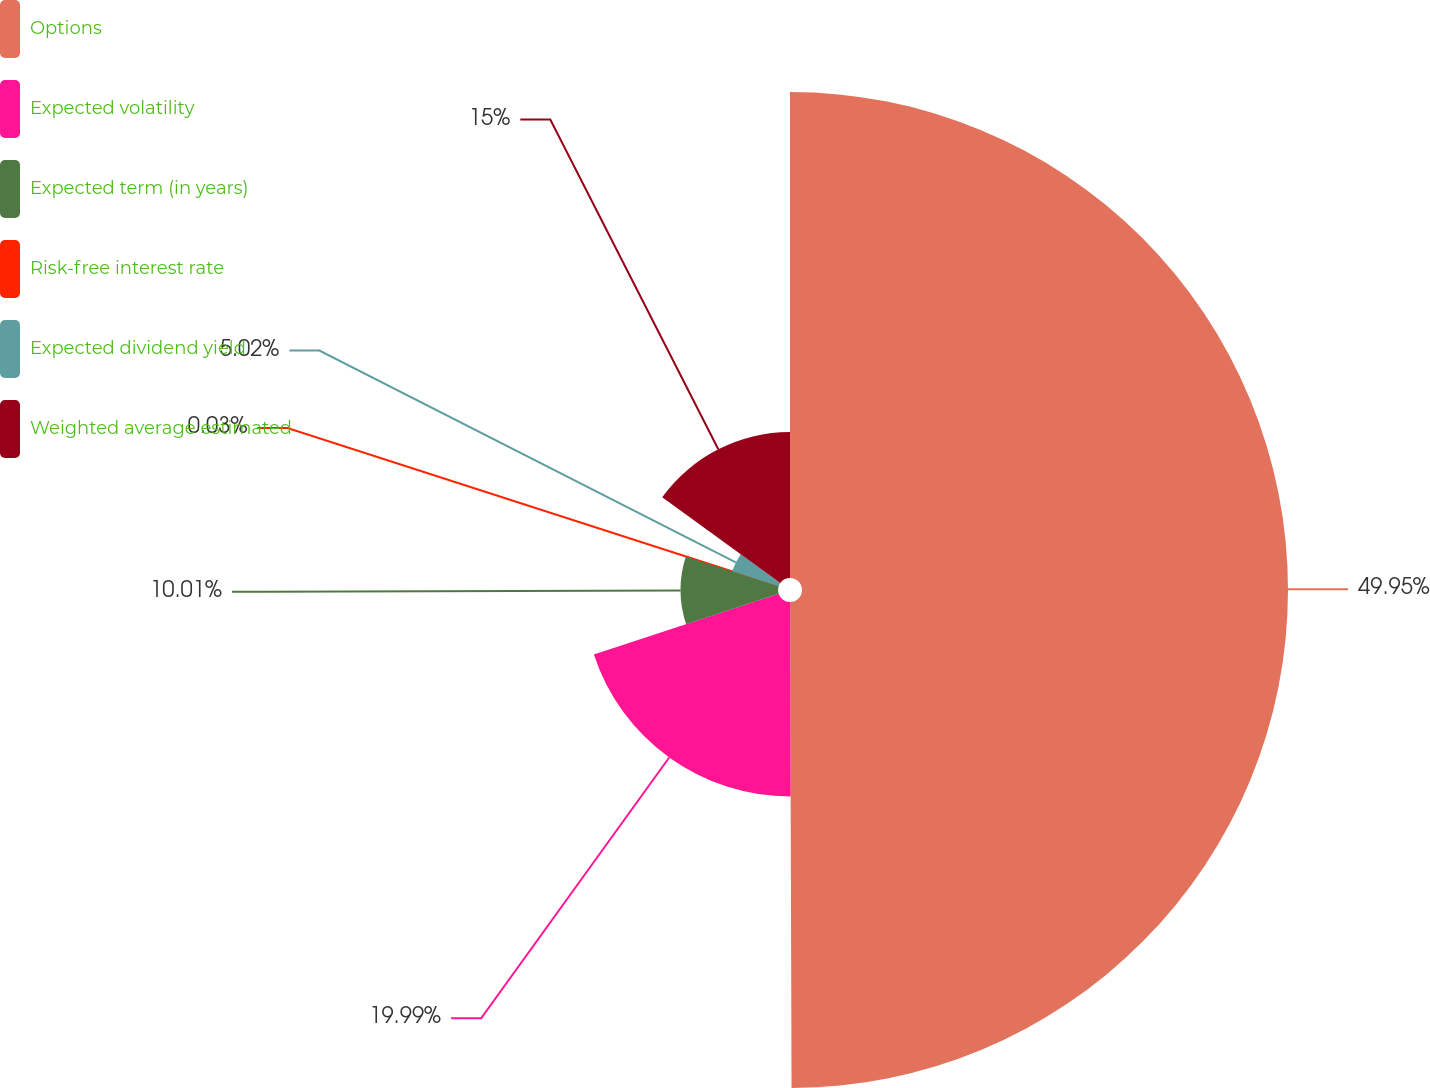<chart> <loc_0><loc_0><loc_500><loc_500><pie_chart><fcel>Options<fcel>Expected volatility<fcel>Expected term (in years)<fcel>Risk-free interest rate<fcel>Expected dividend yield<fcel>Weighted average estimated<nl><fcel>49.95%<fcel>19.99%<fcel>10.01%<fcel>0.03%<fcel>5.02%<fcel>15.0%<nl></chart> 